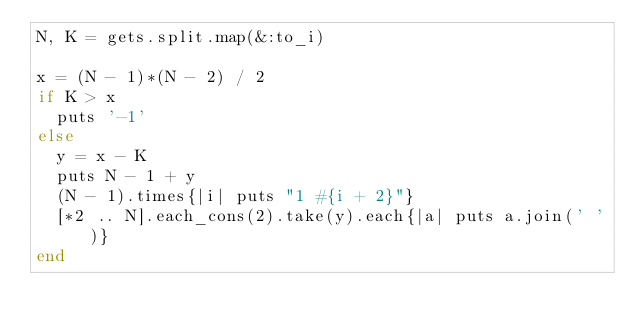Convert code to text. <code><loc_0><loc_0><loc_500><loc_500><_Ruby_>N, K = gets.split.map(&:to_i)

x = (N - 1)*(N - 2) / 2
if K > x
  puts '-1'
else
  y = x - K
  puts N - 1 + y
  (N - 1).times{|i| puts "1 #{i + 2}"}
  [*2 .. N].each_cons(2).take(y).each{|a| puts a.join(' ')}
end</code> 